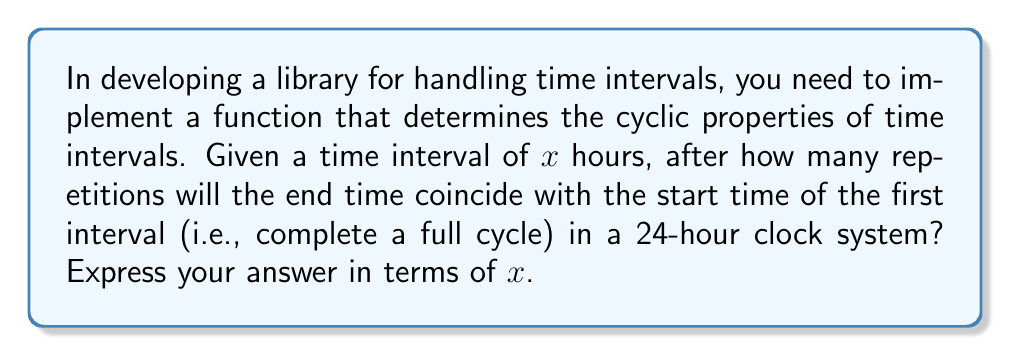Provide a solution to this math problem. To solve this problem, we need to consider the cyclic nature of a 24-hour clock system and how our time interval interacts with it. Let's approach this step-by-step:

1) Let $n$ be the number of repetitions needed to complete a full cycle.

2) The total time elapsed after $n$ repetitions is $nx$ hours.

3) For the end time to coincide with the start time, the total elapsed time must be divisible by 24 (as there are 24 hours in a day).

4) We can express this mathematically as:

   $$nx \equiv 0 \pmod{24}$$

5) This is equivalent to finding the smallest positive integer $n$ such that $nx$ is a multiple of 24.

6) In mathematical terms, we are looking for the least common multiple (LCM) of $x$ and 24, divided by $x$:

   $$n = \frac{LCM(x, 24)}{x}$$

7) We can simplify this using the property that $LCM(a,b) \cdot GCD(a,b) = ab$:

   $$n = \frac{24}{GCD(x, 24)}$$

8) Therefore, the number of repetitions needed is 24 divided by the greatest common divisor of $x$ and 24.

This solution works for any positive real number $x$, allowing for fractional hour intervals which is often necessary in time-handling libraries.
Answer: $n = \frac{24}{GCD(x, 24)}$ 